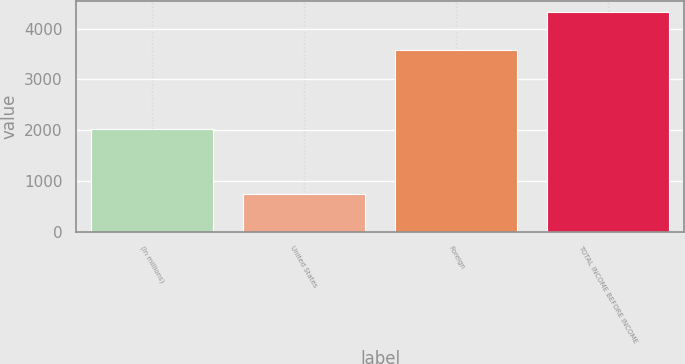<chart> <loc_0><loc_0><loc_500><loc_500><bar_chart><fcel>(In millions)<fcel>United States<fcel>Foreign<fcel>TOTAL INCOME BEFORE INCOME<nl><fcel>2018<fcel>744<fcel>3581<fcel>4325<nl></chart> 